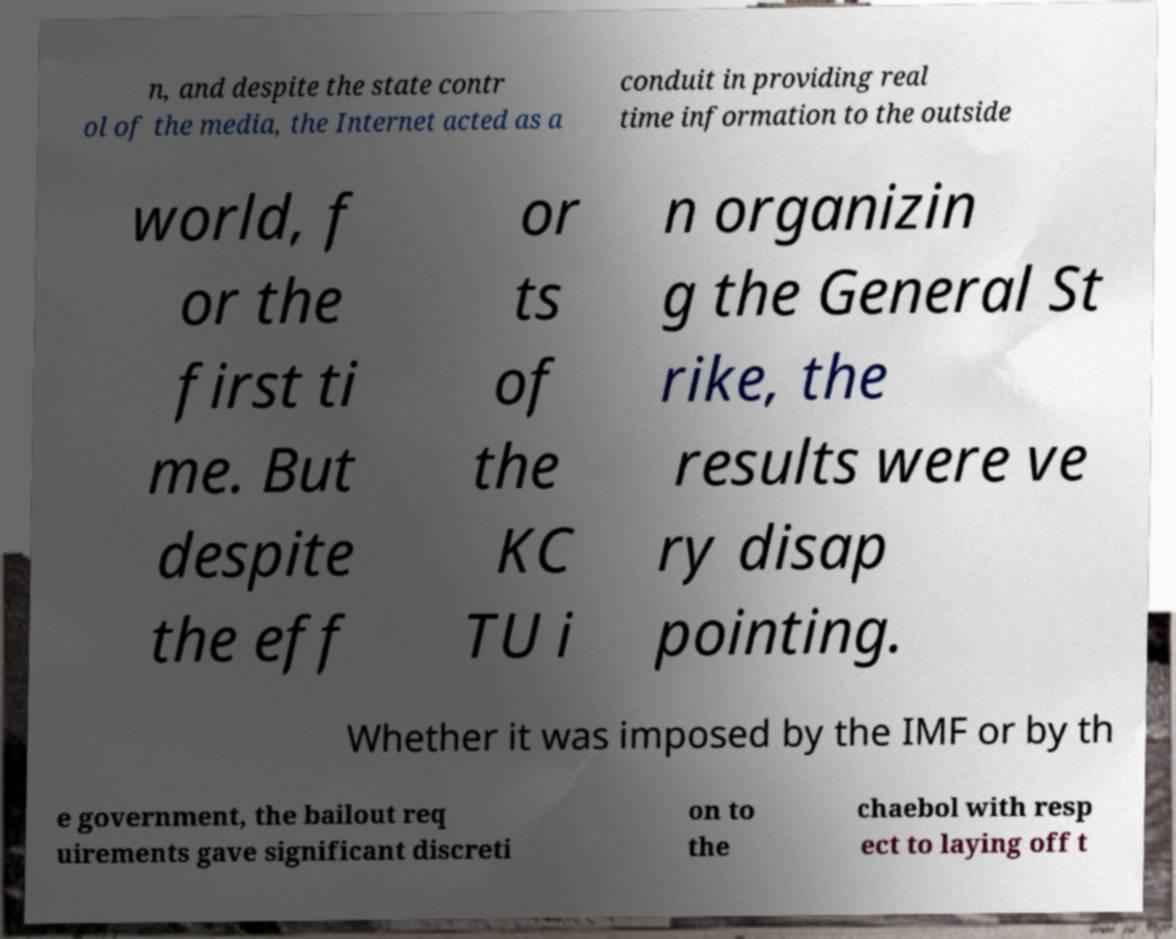Please identify and transcribe the text found in this image. n, and despite the state contr ol of the media, the Internet acted as a conduit in providing real time information to the outside world, f or the first ti me. But despite the eff or ts of the KC TU i n organizin g the General St rike, the results were ve ry disap pointing. Whether it was imposed by the IMF or by th e government, the bailout req uirements gave significant discreti on to the chaebol with resp ect to laying off t 